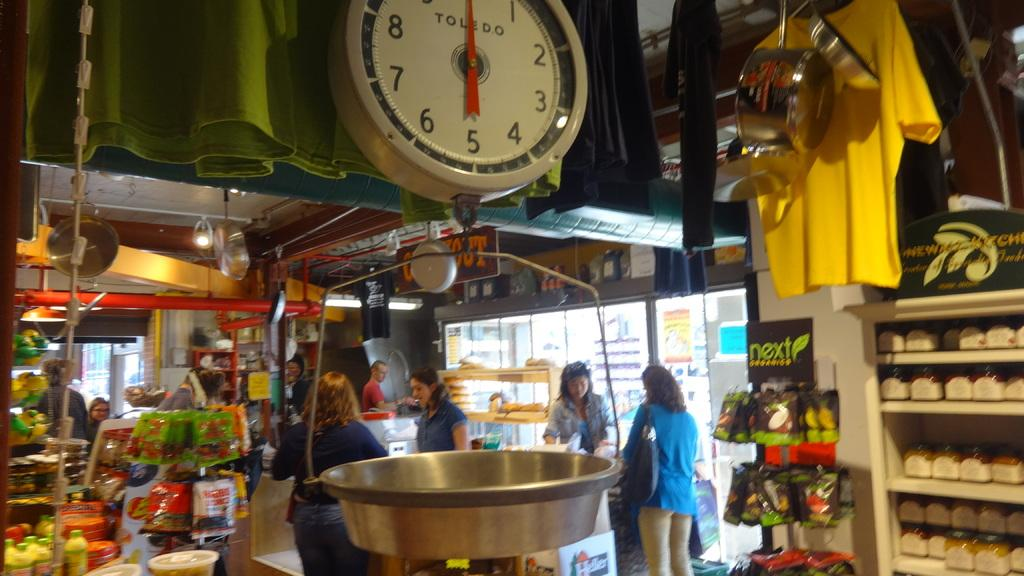<image>
Relay a brief, clear account of the picture shown. A store with 4 people and a display of Next Organics. 